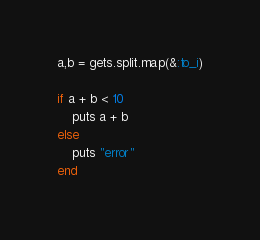<code> <loc_0><loc_0><loc_500><loc_500><_Ruby_>a,b = gets.split.map(&:to_i)

if a + b < 10
    puts a + b
else
    puts "error"
end</code> 